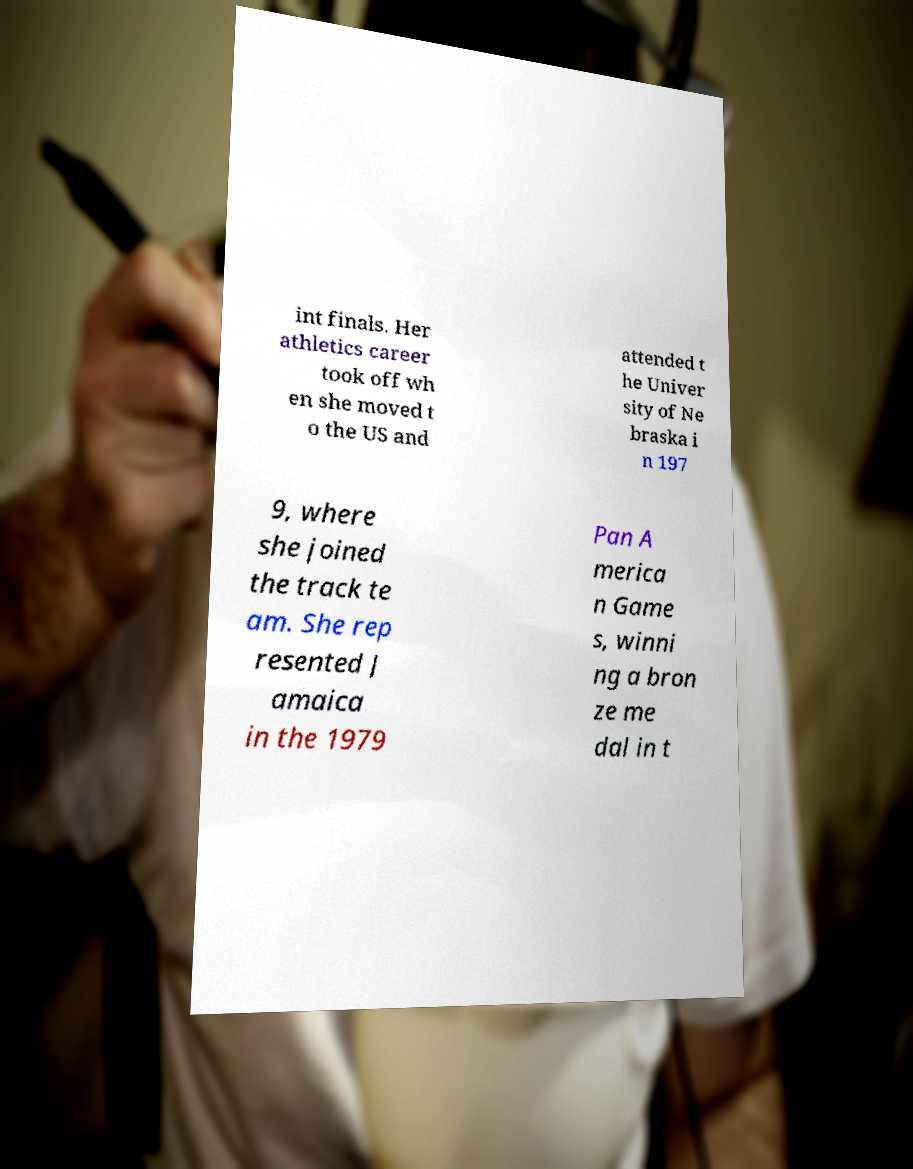Could you extract and type out the text from this image? int finals. Her athletics career took off wh en she moved t o the US and attended t he Univer sity of Ne braska i n 197 9, where she joined the track te am. She rep resented J amaica in the 1979 Pan A merica n Game s, winni ng a bron ze me dal in t 